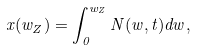<formula> <loc_0><loc_0><loc_500><loc_500>x ( w _ { Z } ) = \int _ { 0 } ^ { w _ { Z } } N ( w , t ) d w ,</formula> 